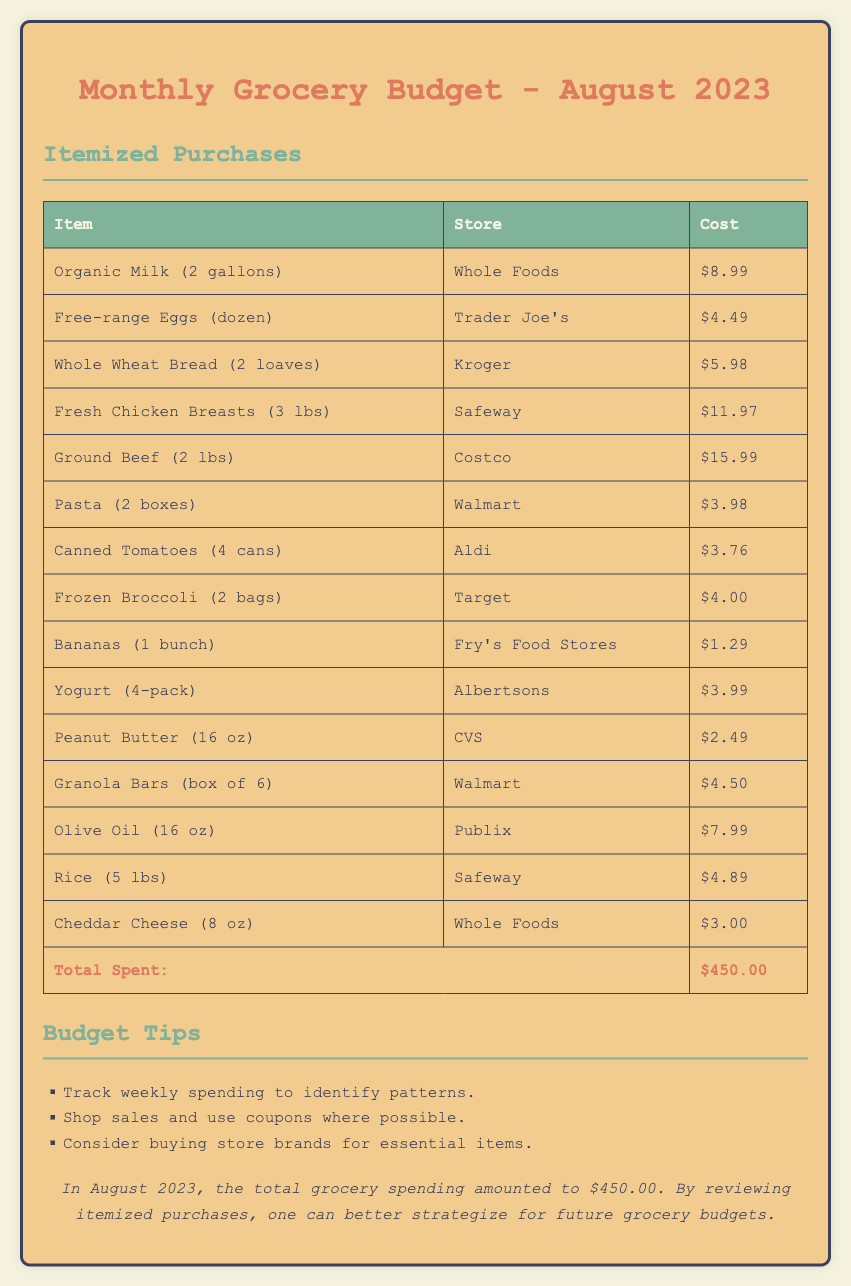What was the total spent on groceries? The document states that the total spent on groceries for August 2023 is located in the itemized purchases table.
Answer: $450.00 How many items were listed in the itemized purchases table? The number of rows in the itemized purchases table indicates the number of items. There are 14 rows (excluding headers).
Answer: 14 Which store sold organic milk? The item for organic milk specifies the store where it was purchased.
Answer: Whole Foods What is the price of the ground beef? The ground beef item has a specific cost listed in the table.
Answer: $15.99 Which item costs the least? The costs of each item can be compared to find the one with the lowest price.
Answer: $1.29 How many pounds of chicken breasts were purchased? The weight of the chicken breasts is mentioned in the item description in the table.
Answer: 3 lbs Which category does this document fall under? The overall focus of the document can be classified based on its content and purpose.
Answer: Budget report What was suggested as a budgeting tip? The document includes a section providing tips related to budgeting grocery expenses.
Answer: Track weekly spending to identify patterns How much did the eggs cost? The price of the eggs is clearly listed in the itemized purchases table.
Answer: $4.49 